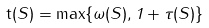Convert formula to latex. <formula><loc_0><loc_0><loc_500><loc_500>\mathsf t ( S ) = \max \{ \omega ( S ) , 1 + \tau ( S ) \}</formula> 